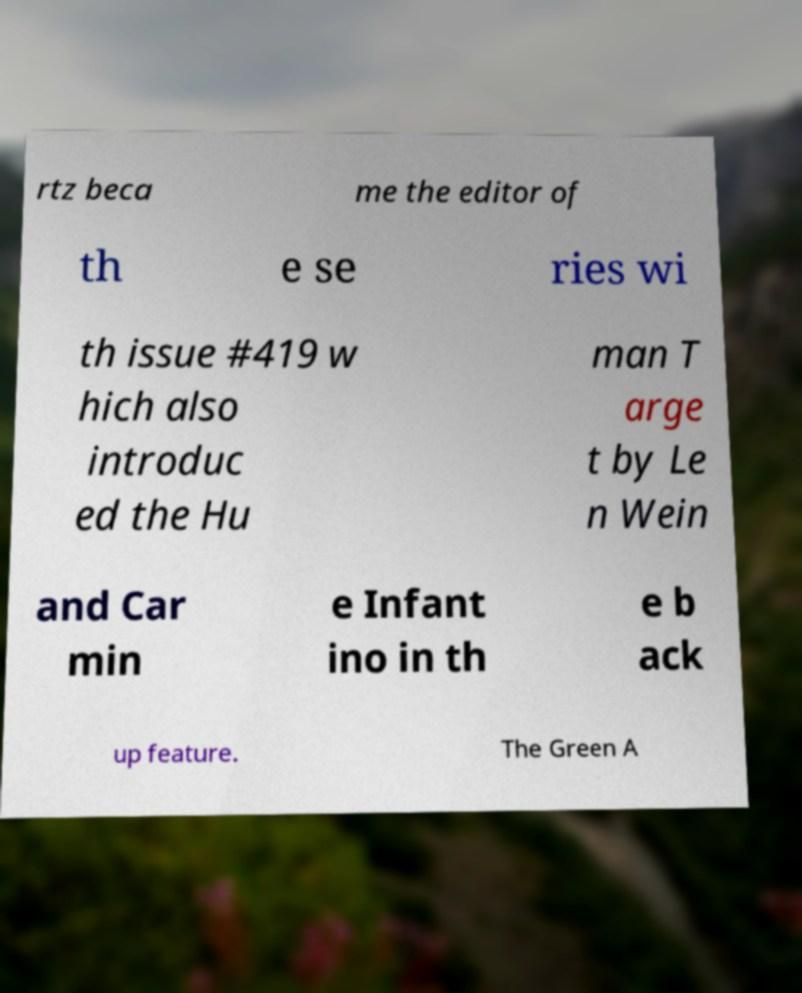What messages or text are displayed in this image? I need them in a readable, typed format. rtz beca me the editor of th e se ries wi th issue #419 w hich also introduc ed the Hu man T arge t by Le n Wein and Car min e Infant ino in th e b ack up feature. The Green A 